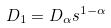Convert formula to latex. <formula><loc_0><loc_0><loc_500><loc_500>D _ { 1 } = D _ { \alpha } s ^ { 1 - \alpha }</formula> 